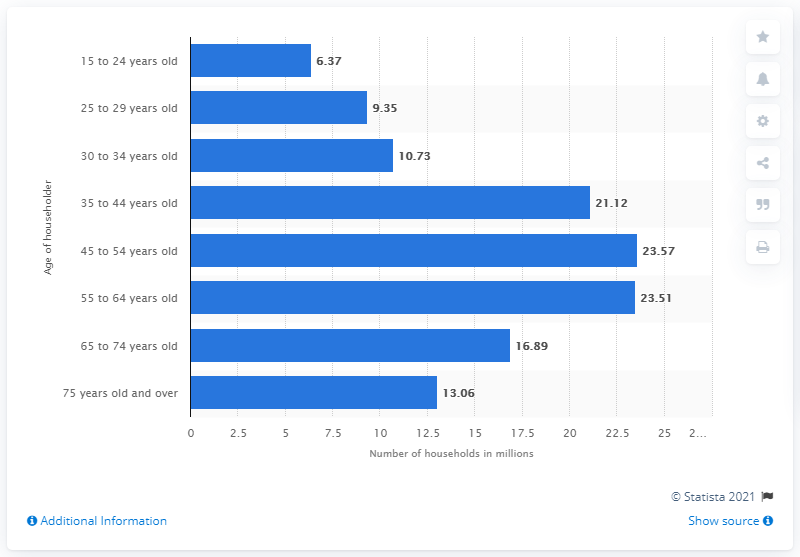Mention a couple of crucial points in this snapshot. In 2015, there were approximately 10.73 households in the United States that were led by individuals between the ages of 30 and 34. 